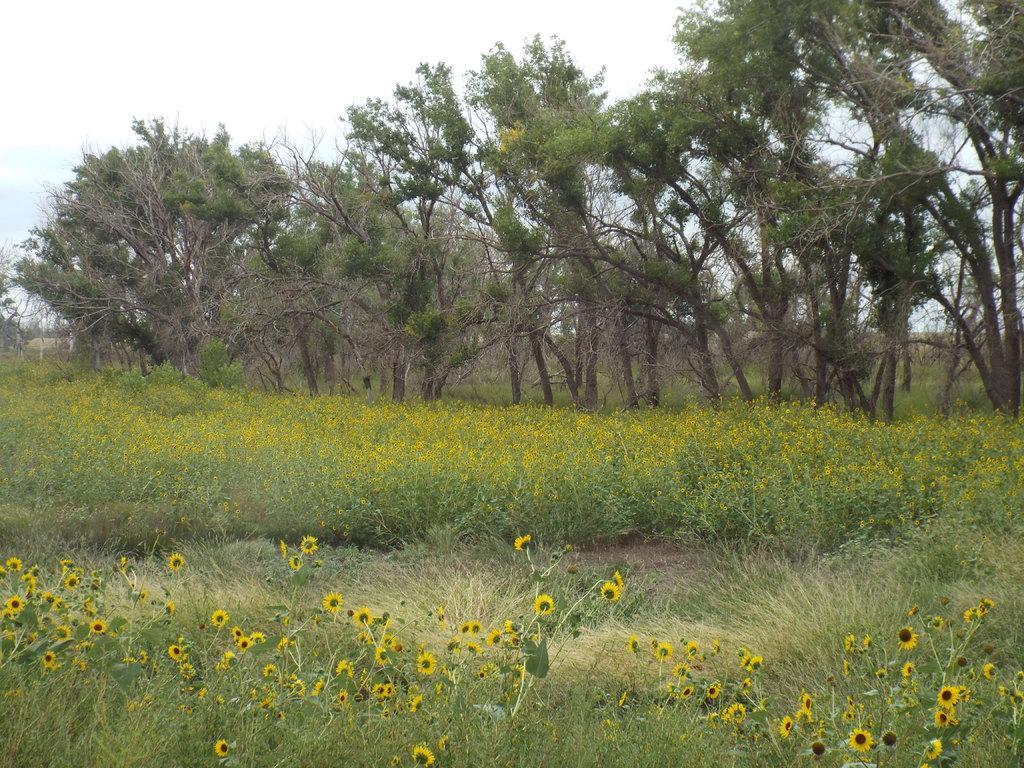How would you summarize this image in a sentence or two? In this picture, we can see the ground with plants, grass, flowers, trees and the sky. 